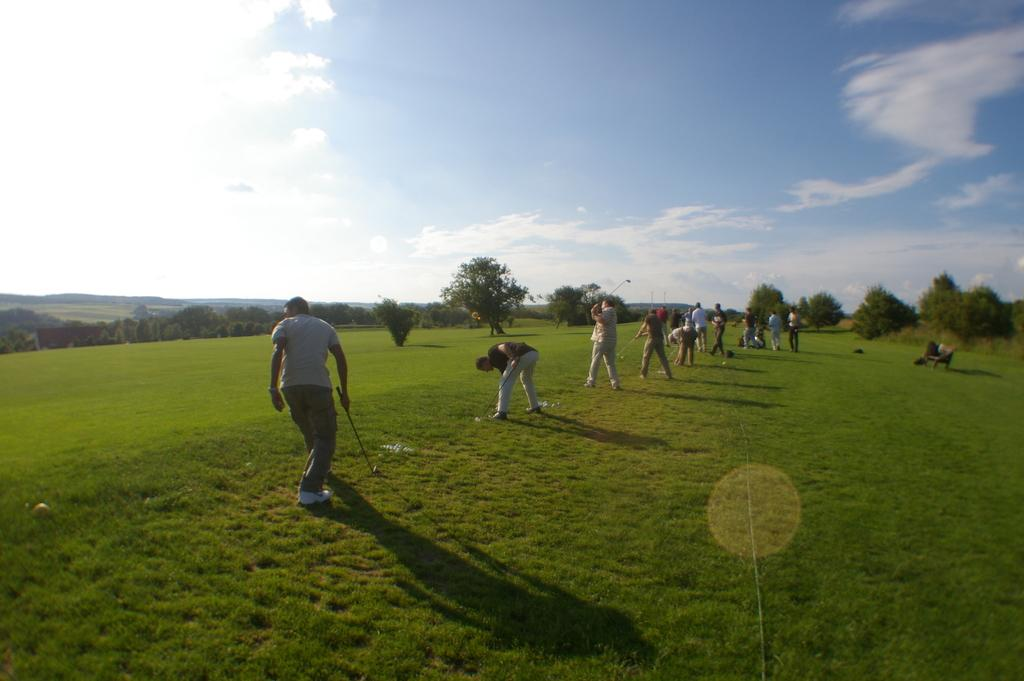What are the people in the image doing? The people in the image are holding hockey bats. What can be seen in the background of the image? There is grass, trees, hills, and the sky visible in the background of the image. What type of plane can be seen flying over the people in the image? There is no plane visible in the image; it only shows a group of people holding hockey bats and the background. 